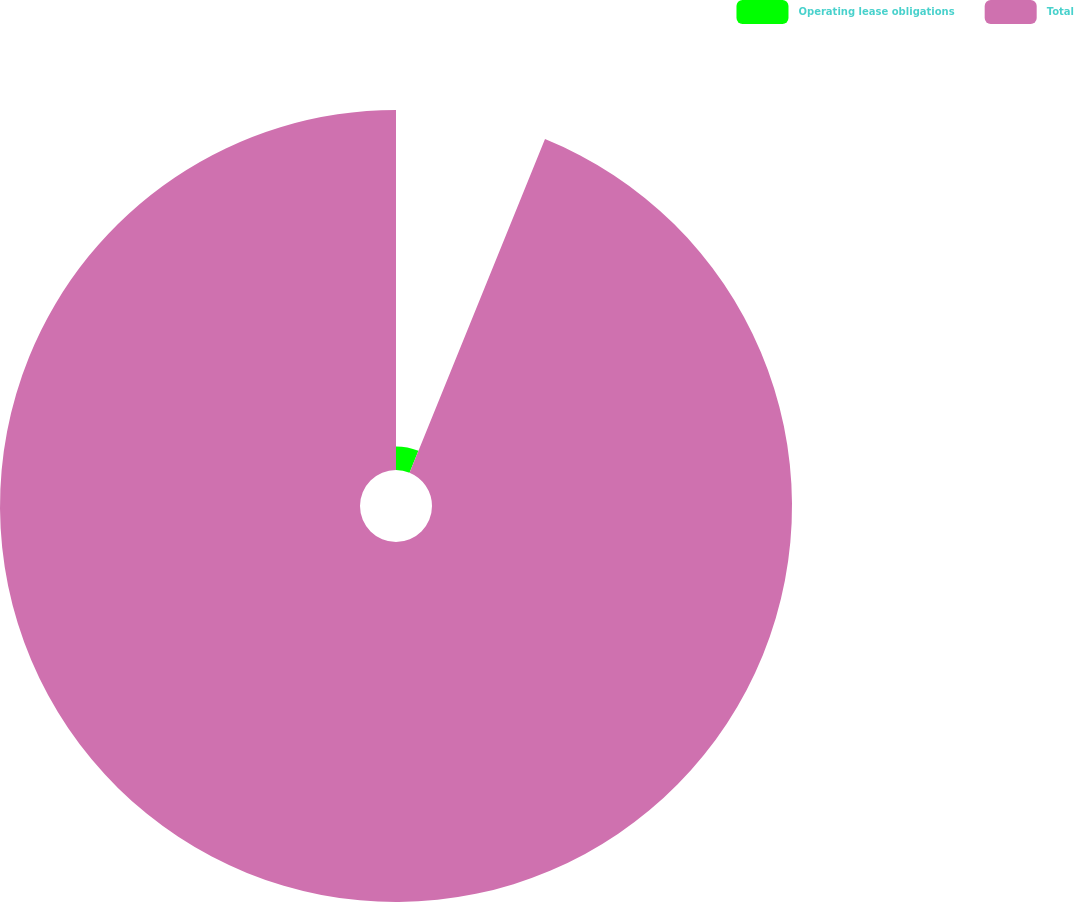Convert chart. <chart><loc_0><loc_0><loc_500><loc_500><pie_chart><fcel>Operating lease obligations<fcel>Total<nl><fcel>6.14%<fcel>93.86%<nl></chart> 